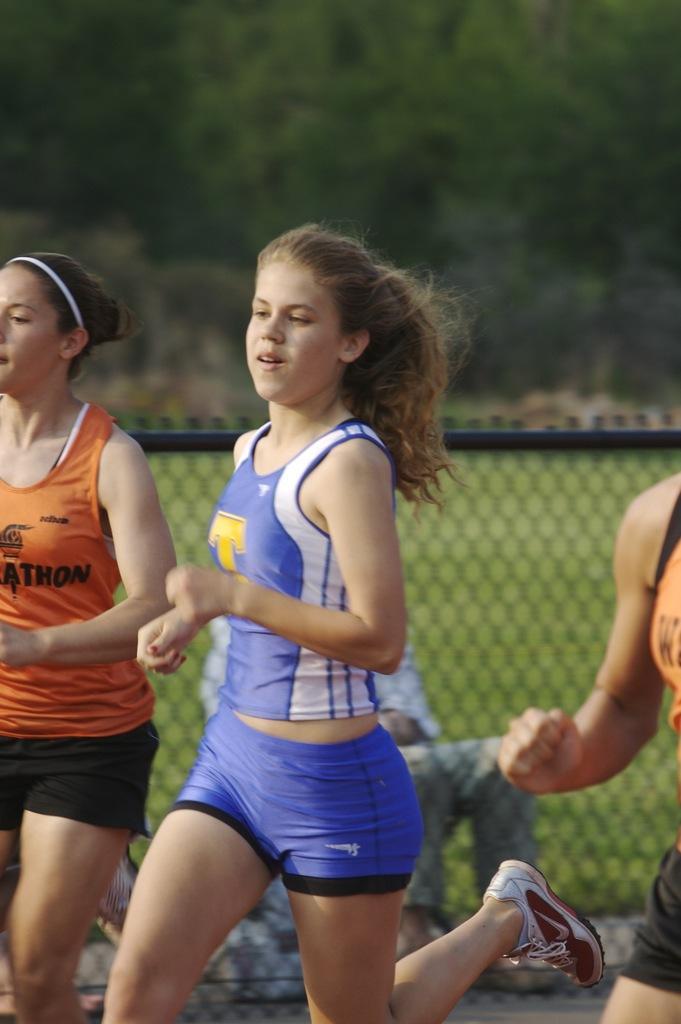Can you describe this image briefly? Here in this picture we can see a group of women running on the ground over there and beside them we can see fencing present and we can see the ground is fully covered with grass over there and in the far we can see plants and trees present all over there. 